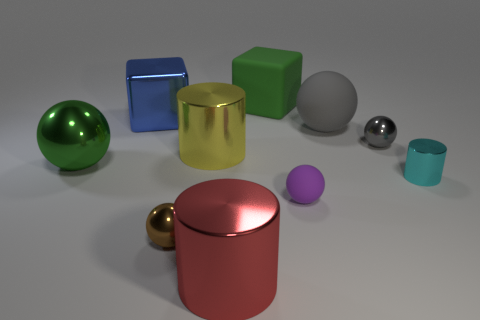Subtract all large cylinders. How many cylinders are left? 1 Subtract all green cylinders. How many gray balls are left? 2 Subtract 2 cubes. How many cubes are left? 0 Subtract all cyan cylinders. How many cylinders are left? 2 Subtract all cylinders. How many objects are left? 7 Subtract all tiny cyan metallic things. Subtract all yellow shiny objects. How many objects are left? 8 Add 2 metal blocks. How many metal blocks are left? 3 Add 7 brown rubber cubes. How many brown rubber cubes exist? 7 Subtract 0 blue spheres. How many objects are left? 10 Subtract all cyan cylinders. Subtract all green blocks. How many cylinders are left? 2 